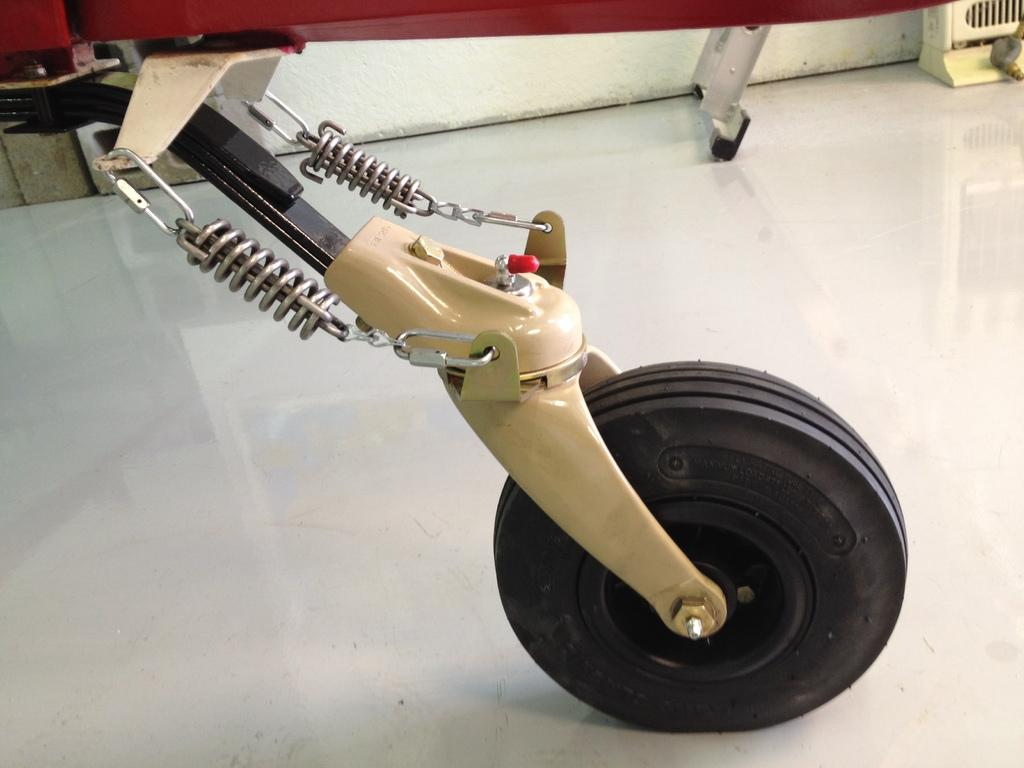What is the main subject of the image? The main subject of the image is a wheel. Can you describe the wheel in the image? The wheel is located in the center of the image. What type of property is being sold in the image? There is no property being sold in the image; it only features a wheel. Can you read any writing on the wheel in the image? There is no writing visible on the wheel in the image. 